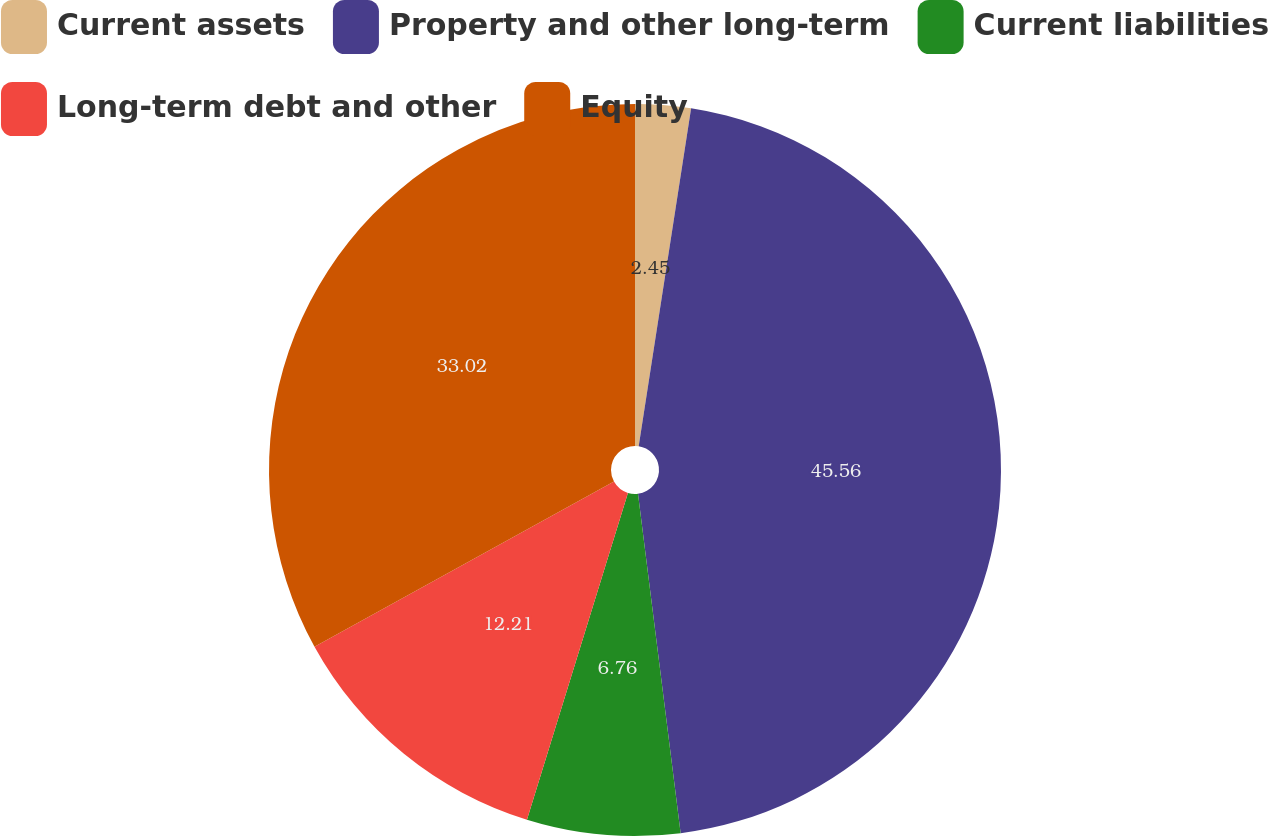Convert chart to OTSL. <chart><loc_0><loc_0><loc_500><loc_500><pie_chart><fcel>Current assets<fcel>Property and other long-term<fcel>Current liabilities<fcel>Long-term debt and other<fcel>Equity<nl><fcel>2.45%<fcel>45.56%<fcel>6.76%<fcel>12.21%<fcel>33.02%<nl></chart> 